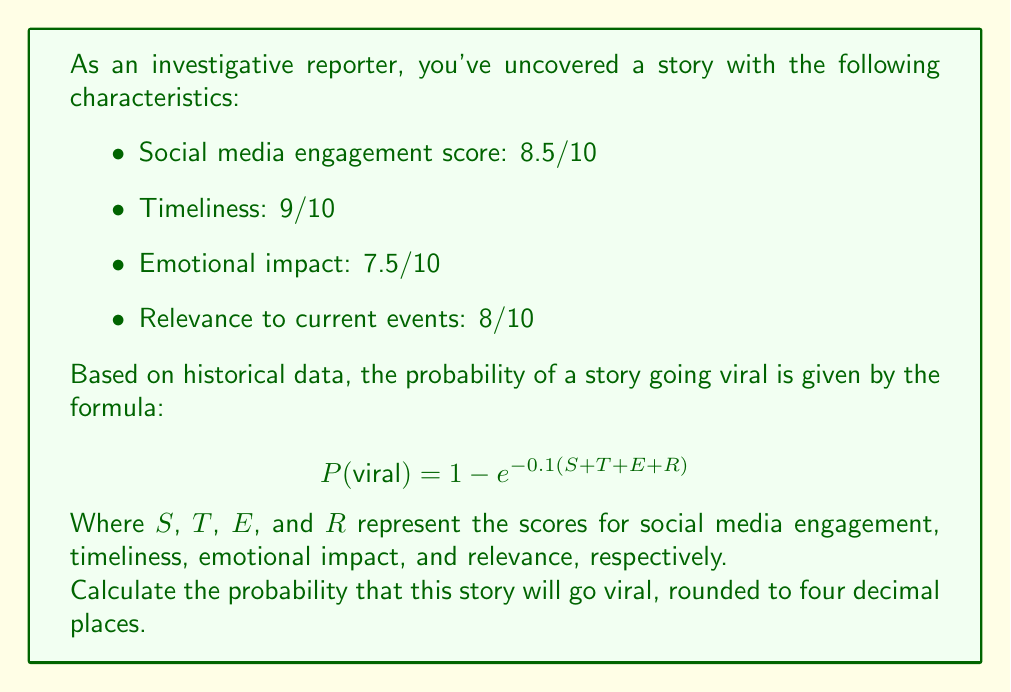What is the answer to this math problem? To solve this problem, we'll follow these steps:

1) First, let's identify the values for each variable:
   $S = 8.5$ (Social media engagement)
   $T = 9$ (Timeliness)
   $E = 7.5$ (Emotional impact)
   $R = 8$ (Relevance to current events)

2) Now, let's sum these values:
   $S + T + E + R = 8.5 + 9 + 7.5 + 8 = 33$

3) We can now plug this sum into the given formula:

   $$ P(\text{viral}) = 1 - e^{-0.1(33)} $$

4) Let's simplify the exponent:
   $-0.1(33) = -3.3$

5) Now our equation looks like this:
   $$ P(\text{viral}) = 1 - e^{-3.3} $$

6) Using a calculator or computer, we can calculate $e^{-3.3}$:
   $e^{-3.3} \approx 0.0367879441$

7) Subtracting this from 1:
   $1 - 0.0367879441 = 0.9632120559$

8) Rounding to four decimal places:
   $0.9632120559 \approx 0.9632$

Therefore, the probability of this story going viral is approximately 0.9632 or 96.32%.
Answer: 0.9632 